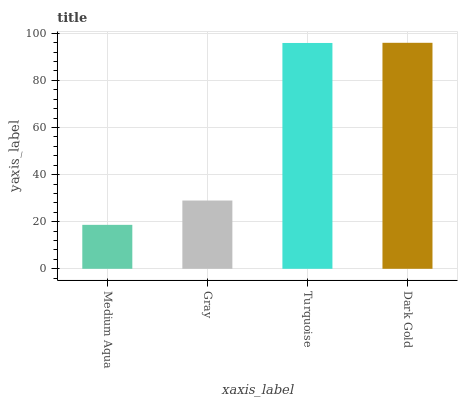Is Medium Aqua the minimum?
Answer yes or no. Yes. Is Dark Gold the maximum?
Answer yes or no. Yes. Is Gray the minimum?
Answer yes or no. No. Is Gray the maximum?
Answer yes or no. No. Is Gray greater than Medium Aqua?
Answer yes or no. Yes. Is Medium Aqua less than Gray?
Answer yes or no. Yes. Is Medium Aqua greater than Gray?
Answer yes or no. No. Is Gray less than Medium Aqua?
Answer yes or no. No. Is Turquoise the high median?
Answer yes or no. Yes. Is Gray the low median?
Answer yes or no. Yes. Is Dark Gold the high median?
Answer yes or no. No. Is Dark Gold the low median?
Answer yes or no. No. 